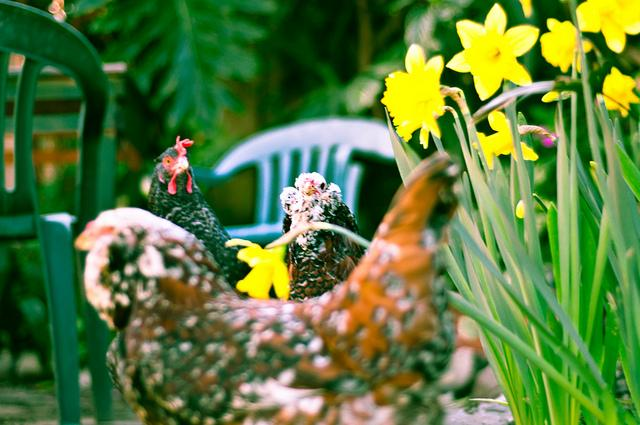What animal is near the flowers? chicken 